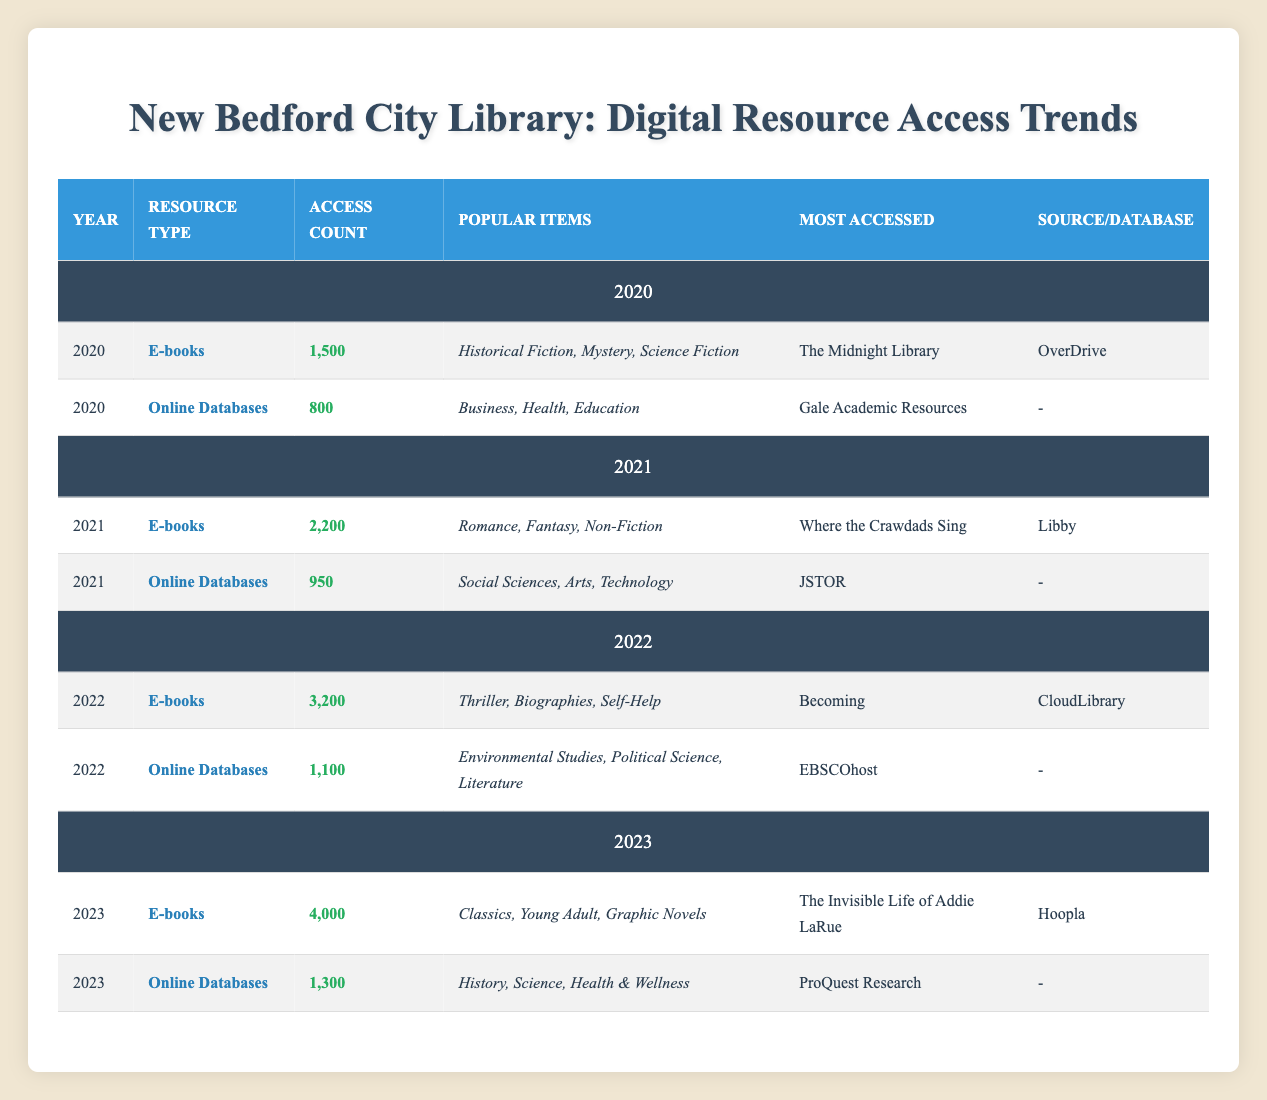What was the most accessed e-book in 2022? The table shows that in 2022, the most accessed e-book was "Becoming." This is located in the row corresponding to the year 2022 under the e-books section.
Answer: Becoming How many total accesses were there for e-books in 2021 and 2022 together? To find the total accesses for e-books in 2021 and 2022, you sum the access counts for those years: 2200 (2021) + 3200 (2022) = 5400.
Answer: 5400 Was the access count for online databases in 2023 higher than in 2022? For online databases, the access count in 2023 is 1300, and in 2022 it is 1100. Since 1300 is greater than 1100, the statement is true.
Answer: Yes What genre was the most popular for e-books in 2023? According to the table, the most popular genres for e-books in 2023 are Classics, Young Adult, and Graphic Novels. These are listed in the row for 2023 under e-books.
Answer: Classics, Young Adult, Graphic Novels How much did access count grow for e-books from 2020 to 2023? To calculate the growth, subtract the access count of e-books in 2020 (1500) from that in 2023 (4000): 4000 - 1500 = 2500. This indicates a gain of 2500 total accesses over the selected years.
Answer: 2500 Which online database had the highest access count in 2021? Referring to the table for 2021, the highest access count for online databases was for JSTOR with an access count of 950. This is evident from the data for that year.
Answer: JSTOR Is "The Invisible Life of Addie LaRue" the most accessed title for e-books in 2022? The table indicates that "The Invisible Life of Addie LaRue" was the most accessed title in 2023, while in 2022, the most accessed title was "Becoming." Thus, the statement is false.
Answer: No Calculate the average access count for online databases over the years listed. The access counts for online databases over the years are 800 (2020), 950 (2021), 1100 (2022), and 1300 (2023). The sum of these counts is 800 + 950 + 1100 + 1300 = 4150. There are 4 data points, so the average is 4150 / 4 = 1037.5.
Answer: 1037.5 What were the popular subjects for online databases in 2022? In the row for online databases for the year 2022, the popular subjects are Environmental Studies, Political Science, and Literature. These subjects are clearly listed in the table for that year.
Answer: Environmental Studies, Political Science, Literature 